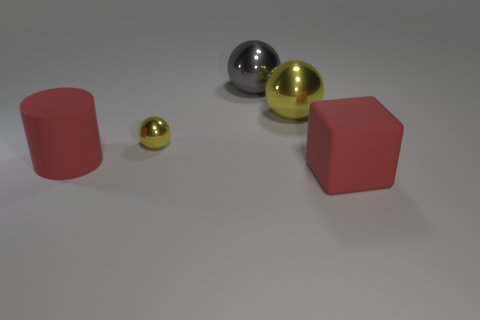What is the shape of the large object that is the same material as the cylinder?
Offer a terse response. Cube. There is a gray object that is on the right side of the large red rubber cylinder; is it the same shape as the small yellow thing?
Provide a succinct answer. Yes. There is a object that is both behind the tiny yellow metallic sphere and left of the big yellow sphere; what material is it?
Your response must be concise. Metal. There is a yellow metallic thing that is on the left side of the yellow ball that is to the right of the big gray metallic object; what size is it?
Keep it short and to the point. Small. Does the gray shiny thing have the same shape as the tiny thing?
Give a very brief answer. Yes. What color is the big cube that is the same material as the cylinder?
Provide a succinct answer. Red. There is a large red object in front of the red rubber object that is left of the large red cube; what is it made of?
Provide a short and direct response. Rubber. Are there fewer big yellow metal things that are in front of the large yellow object than balls right of the tiny yellow ball?
Keep it short and to the point. Yes. There is a large thing that is the same color as the cylinder; what is its material?
Provide a short and direct response. Rubber. Are there any other things that have the same shape as the tiny thing?
Give a very brief answer. Yes. 